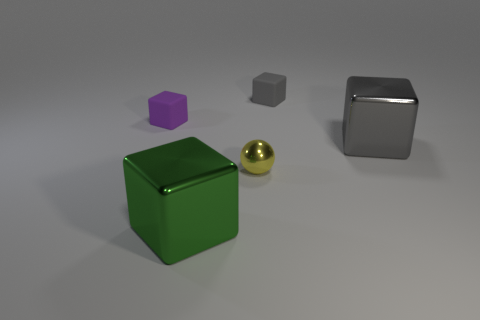Can you describe the different shapes and materials of the objects shown in the image? Certainly! The image displays five distinct 3D objects. Starting from the left, we have a large green cube with a shiny surface, possibly made of plastic. Next to it is a reflective golden sphere, which has a metallic finish. Moving right, we see a smaller gray cube, likely made of a similar material to the green one. Above it floats a small purple hexagonal prism with a matte finish. Finally, on the far right, there's a large reflective cube with a chromed finish, suggesting a metal composition. 